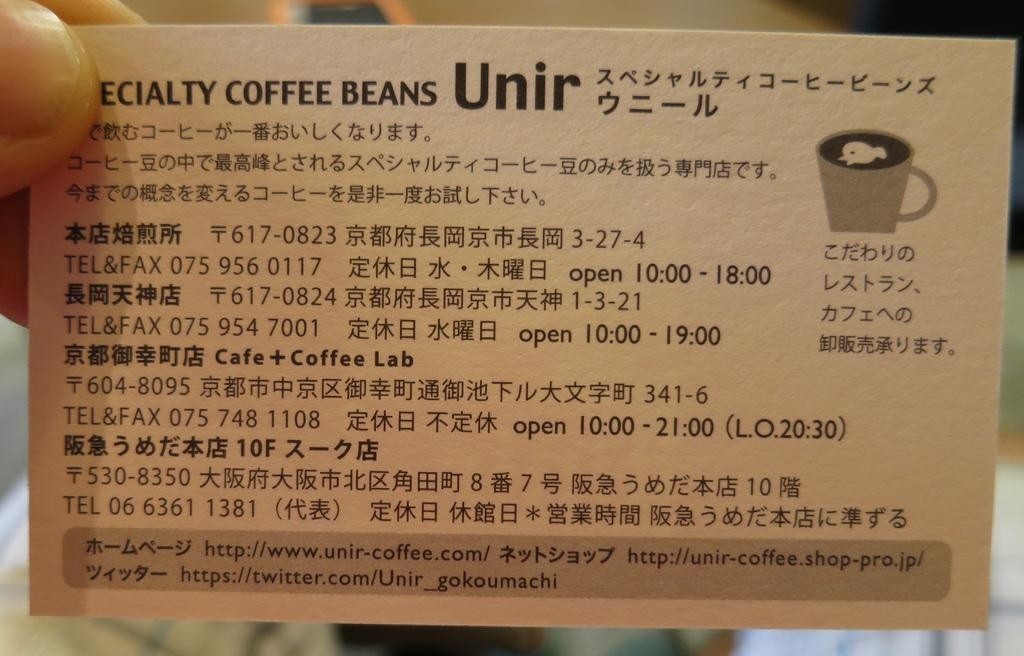Who is in the image? There is a person in the image. What is the person holding in the image? The person is holding a small information card. What information can be found on the card? The card has a name on it, which is related to specialty coffee beans. What else is depicted beside the card? There is a cup image beside the card. How does the person balance the card and cup image in the image? The person is not balancing the card and cup image in the image; they are simply holding the card, and the cup image is beside it. 